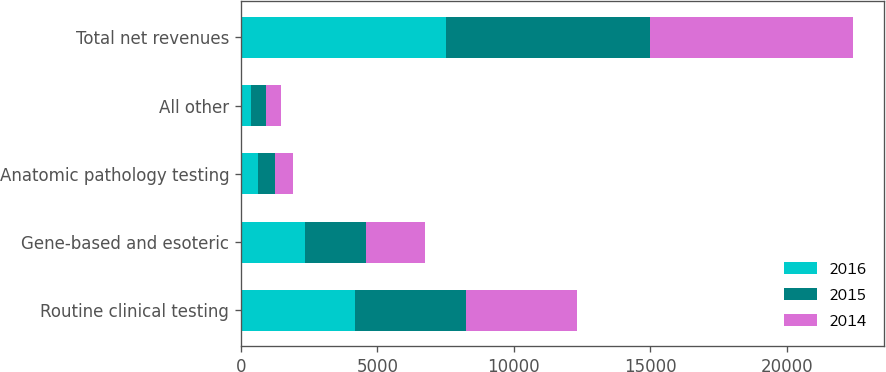<chart> <loc_0><loc_0><loc_500><loc_500><stacked_bar_chart><ecel><fcel>Routine clinical testing<fcel>Gene-based and esoteric<fcel>Anatomic pathology testing<fcel>All other<fcel>Total net revenues<nl><fcel>2016<fcel>4179<fcel>2335<fcel>624<fcel>377<fcel>7515<nl><fcel>2015<fcel>4078<fcel>2256<fcel>631<fcel>528<fcel>7493<nl><fcel>2014<fcel>4066<fcel>2158<fcel>649<fcel>562<fcel>7435<nl></chart> 